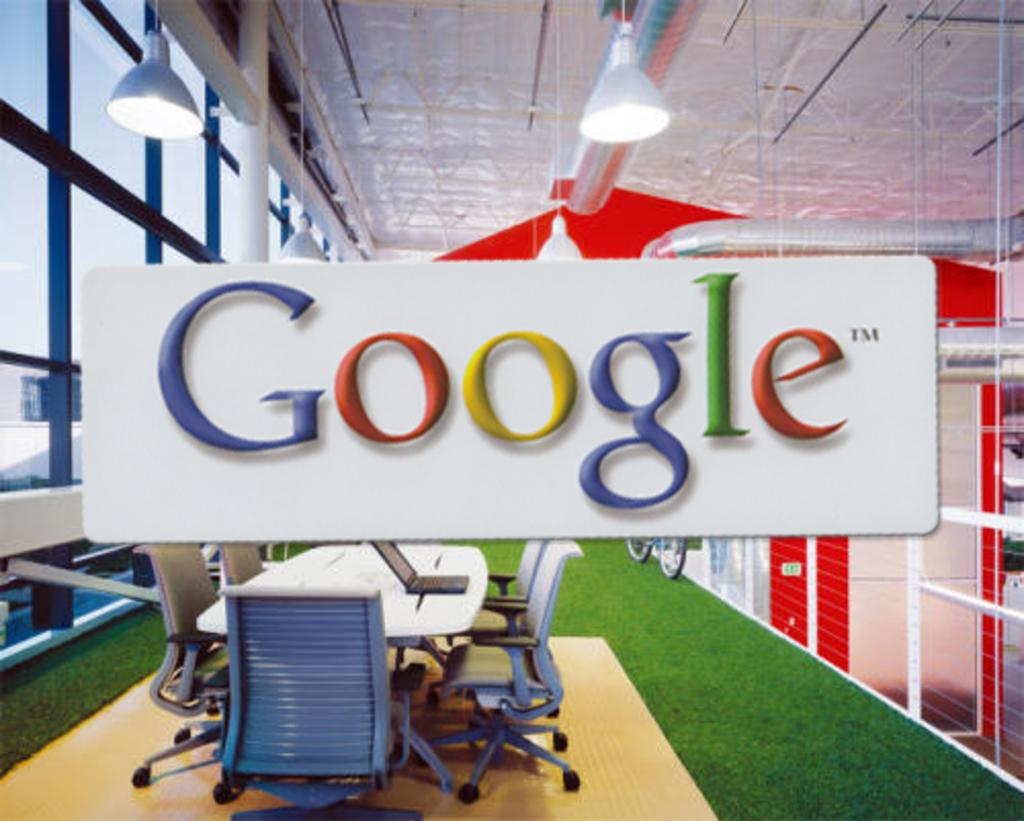Where is the location of the image? The image is inside a building. What can be seen on the walls or surfaces in the image? There is text visible in the image. What type of furniture is present in the image? There are chairs in the image. Is there any furniture for placing objects or for people to gather around? Yes, a table is arranged in the image. What type of lead can be seen being used in the image? There is no lead present in the image, nor is there any indication of its use. Can you provide an example of the text visible in the image? The provided facts do not include the specific text visible in the image, so it cannot be quoted or described in detail. 